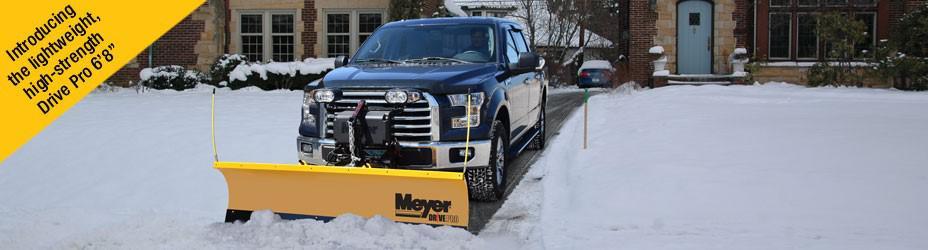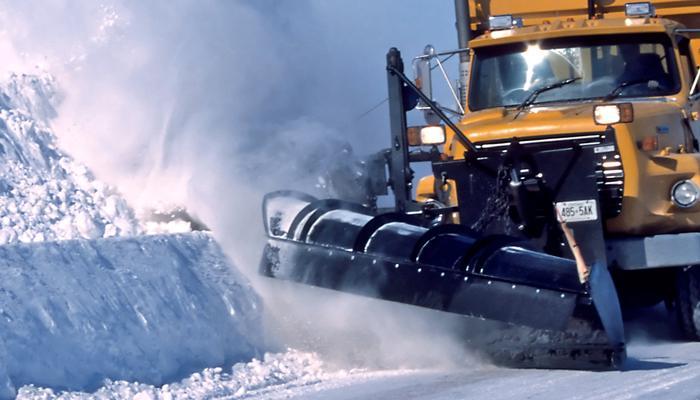The first image is the image on the left, the second image is the image on the right. Evaluate the accuracy of this statement regarding the images: "An image shows a box-shaped machine with a plow, which has no human driver and no truck pulling it.". Is it true? Answer yes or no. No. 